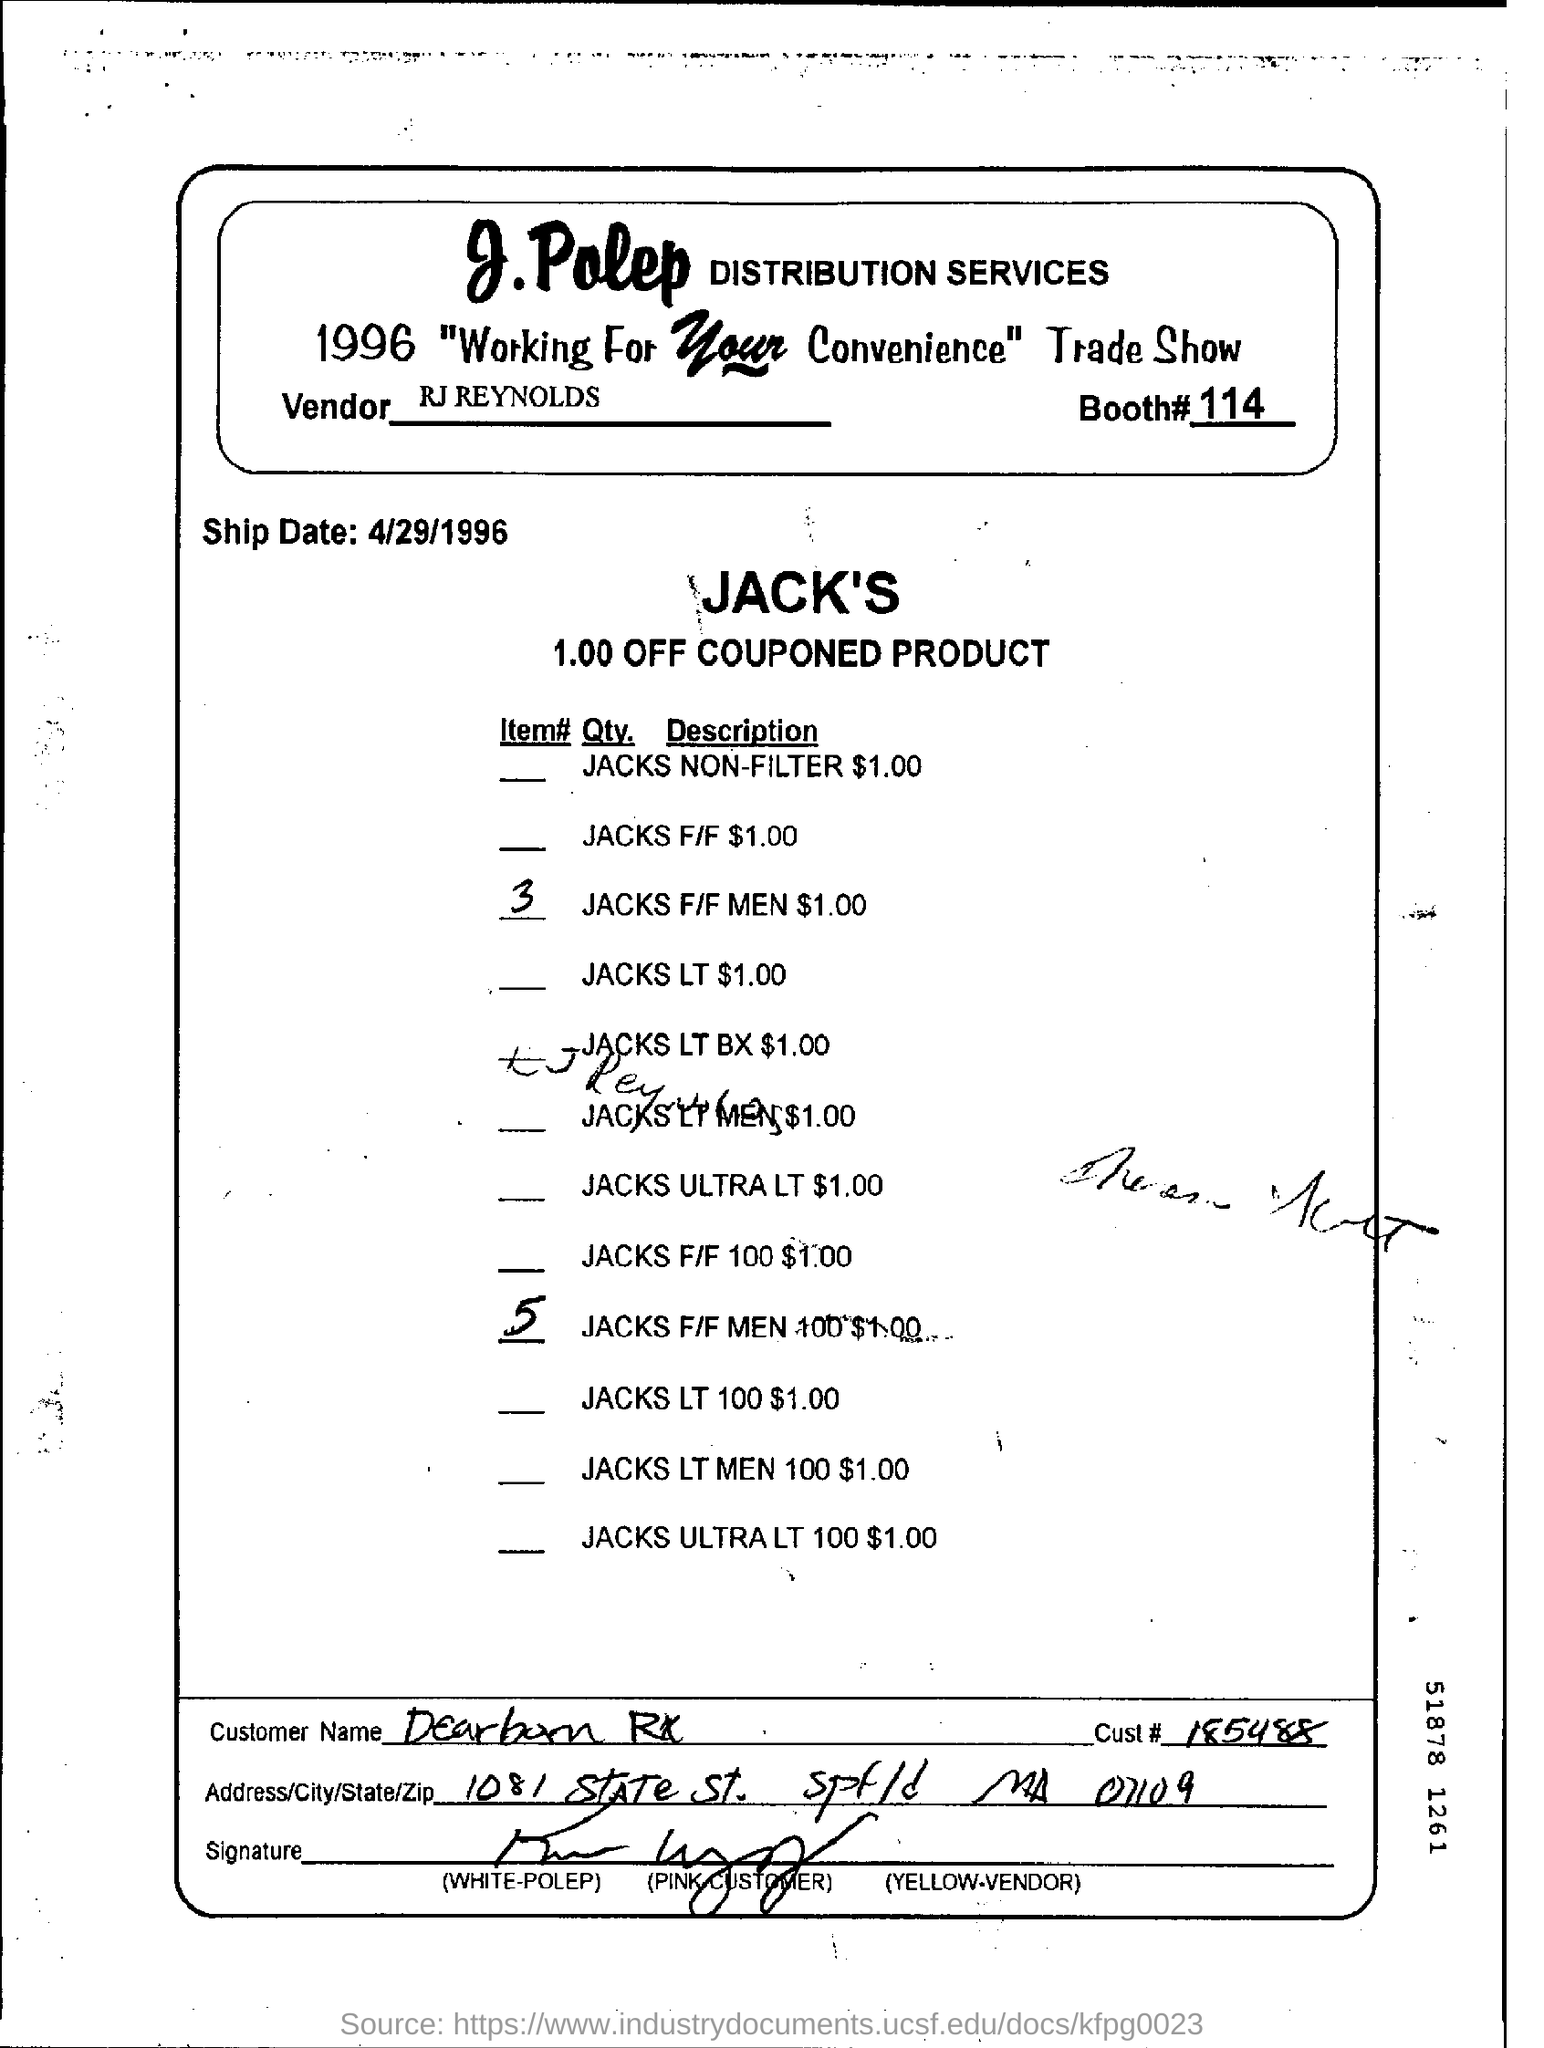Who is the vendor?
Make the answer very short. RJ REYNOLDS. What is booth #?
Provide a short and direct response. 114. What is the ship date?
Your answer should be very brief. 4/29/1996. What is the cust number?
Offer a very short reply. 185488. 